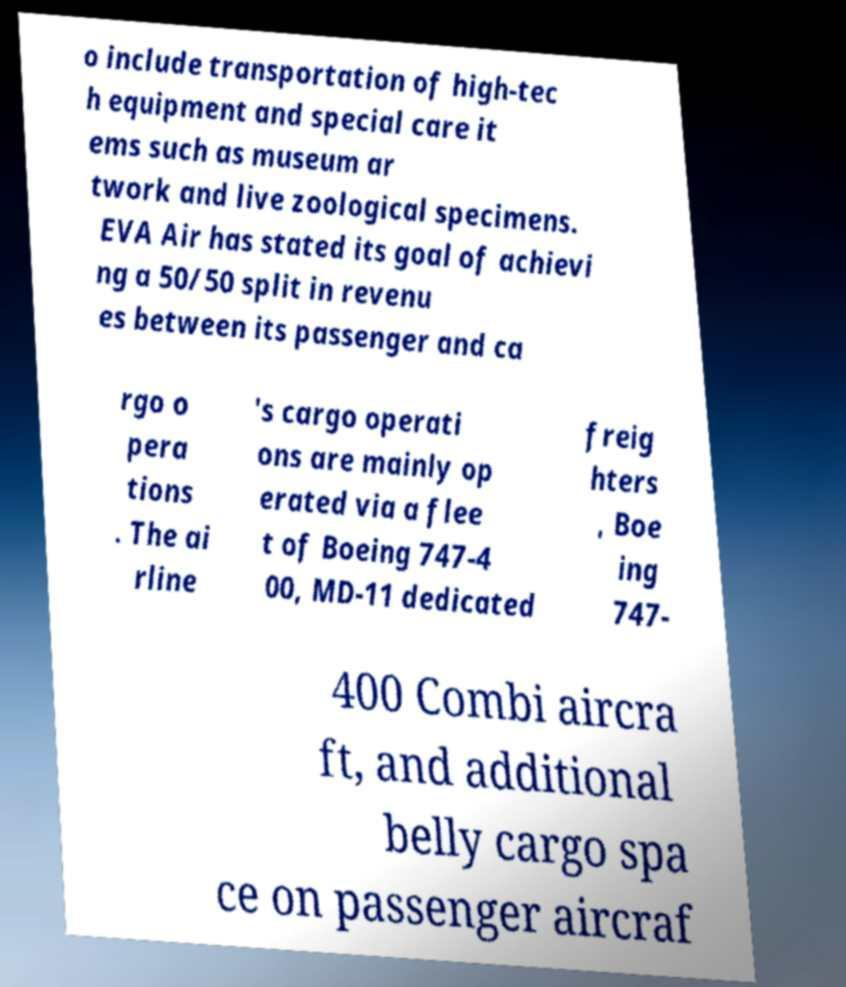Please read and relay the text visible in this image. What does it say? o include transportation of high-tec h equipment and special care it ems such as museum ar twork and live zoological specimens. EVA Air has stated its goal of achievi ng a 50/50 split in revenu es between its passenger and ca rgo o pera tions . The ai rline 's cargo operati ons are mainly op erated via a flee t of Boeing 747-4 00, MD-11 dedicated freig hters , Boe ing 747- 400 Combi aircra ft, and additional belly cargo spa ce on passenger aircraf 